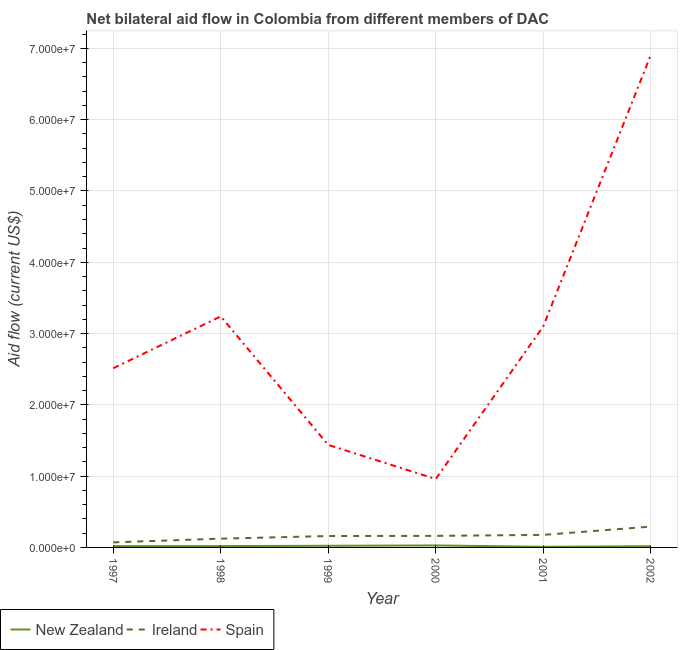Does the line corresponding to amount of aid provided by new zealand intersect with the line corresponding to amount of aid provided by ireland?
Provide a succinct answer. No. Is the number of lines equal to the number of legend labels?
Give a very brief answer. Yes. What is the amount of aid provided by new zealand in 2000?
Give a very brief answer. 2.80e+05. Across all years, what is the maximum amount of aid provided by spain?
Your response must be concise. 6.90e+07. Across all years, what is the minimum amount of aid provided by ireland?
Your answer should be compact. 7.10e+05. In which year was the amount of aid provided by ireland minimum?
Make the answer very short. 1997. What is the total amount of aid provided by new zealand in the graph?
Provide a short and direct response. 1.15e+06. What is the difference between the amount of aid provided by spain in 2000 and that in 2001?
Ensure brevity in your answer.  -2.14e+07. What is the difference between the amount of aid provided by spain in 1999 and the amount of aid provided by ireland in 2000?
Ensure brevity in your answer.  1.28e+07. What is the average amount of aid provided by new zealand per year?
Ensure brevity in your answer.  1.92e+05. In the year 2001, what is the difference between the amount of aid provided by spain and amount of aid provided by ireland?
Your answer should be very brief. 2.92e+07. What is the ratio of the amount of aid provided by spain in 1997 to that in 1999?
Offer a very short reply. 1.75. Is the difference between the amount of aid provided by spain in 1997 and 2001 greater than the difference between the amount of aid provided by ireland in 1997 and 2001?
Make the answer very short. No. What is the difference between the highest and the second highest amount of aid provided by spain?
Offer a very short reply. 3.66e+07. What is the difference between the highest and the lowest amount of aid provided by new zealand?
Keep it short and to the point. 1.90e+05. In how many years, is the amount of aid provided by spain greater than the average amount of aid provided by spain taken over all years?
Offer a very short reply. 3. Is the sum of the amount of aid provided by spain in 2000 and 2001 greater than the maximum amount of aid provided by new zealand across all years?
Give a very brief answer. Yes. Is it the case that in every year, the sum of the amount of aid provided by new zealand and amount of aid provided by ireland is greater than the amount of aid provided by spain?
Your response must be concise. No. Is the amount of aid provided by ireland strictly less than the amount of aid provided by spain over the years?
Provide a succinct answer. Yes. How many lines are there?
Ensure brevity in your answer.  3. What is the difference between two consecutive major ticks on the Y-axis?
Your response must be concise. 1.00e+07. Does the graph contain grids?
Provide a succinct answer. Yes. Where does the legend appear in the graph?
Keep it short and to the point. Bottom left. What is the title of the graph?
Your answer should be compact. Net bilateral aid flow in Colombia from different members of DAC. Does "Negligence towards kids" appear as one of the legend labels in the graph?
Provide a short and direct response. No. What is the Aid flow (current US$) of New Zealand in 1997?
Provide a short and direct response. 1.90e+05. What is the Aid flow (current US$) of Ireland in 1997?
Your answer should be very brief. 7.10e+05. What is the Aid flow (current US$) of Spain in 1997?
Offer a very short reply. 2.51e+07. What is the Aid flow (current US$) of New Zealand in 1998?
Offer a very short reply. 1.90e+05. What is the Aid flow (current US$) in Ireland in 1998?
Make the answer very short. 1.23e+06. What is the Aid flow (current US$) of Spain in 1998?
Offer a very short reply. 3.24e+07. What is the Aid flow (current US$) in New Zealand in 1999?
Make the answer very short. 2.30e+05. What is the Aid flow (current US$) in Ireland in 1999?
Provide a short and direct response. 1.60e+06. What is the Aid flow (current US$) in Spain in 1999?
Make the answer very short. 1.44e+07. What is the Aid flow (current US$) in New Zealand in 2000?
Offer a very short reply. 2.80e+05. What is the Aid flow (current US$) of Ireland in 2000?
Give a very brief answer. 1.62e+06. What is the Aid flow (current US$) in Spain in 2000?
Ensure brevity in your answer.  9.60e+06. What is the Aid flow (current US$) of New Zealand in 2001?
Your response must be concise. 9.00e+04. What is the Aid flow (current US$) in Ireland in 2001?
Offer a very short reply. 1.76e+06. What is the Aid flow (current US$) of Spain in 2001?
Offer a very short reply. 3.10e+07. What is the Aid flow (current US$) of Ireland in 2002?
Offer a very short reply. 2.92e+06. What is the Aid flow (current US$) in Spain in 2002?
Your answer should be compact. 6.90e+07. Across all years, what is the maximum Aid flow (current US$) of Ireland?
Your response must be concise. 2.92e+06. Across all years, what is the maximum Aid flow (current US$) of Spain?
Make the answer very short. 6.90e+07. Across all years, what is the minimum Aid flow (current US$) in New Zealand?
Provide a short and direct response. 9.00e+04. Across all years, what is the minimum Aid flow (current US$) in Ireland?
Offer a terse response. 7.10e+05. Across all years, what is the minimum Aid flow (current US$) in Spain?
Give a very brief answer. 9.60e+06. What is the total Aid flow (current US$) in New Zealand in the graph?
Make the answer very short. 1.15e+06. What is the total Aid flow (current US$) of Ireland in the graph?
Your answer should be compact. 9.84e+06. What is the total Aid flow (current US$) in Spain in the graph?
Give a very brief answer. 1.82e+08. What is the difference between the Aid flow (current US$) in Ireland in 1997 and that in 1998?
Ensure brevity in your answer.  -5.20e+05. What is the difference between the Aid flow (current US$) of Spain in 1997 and that in 1998?
Your answer should be compact. -7.27e+06. What is the difference between the Aid flow (current US$) of New Zealand in 1997 and that in 1999?
Your answer should be compact. -4.00e+04. What is the difference between the Aid flow (current US$) in Ireland in 1997 and that in 1999?
Offer a very short reply. -8.90e+05. What is the difference between the Aid flow (current US$) of Spain in 1997 and that in 1999?
Your answer should be compact. 1.08e+07. What is the difference between the Aid flow (current US$) in Ireland in 1997 and that in 2000?
Offer a very short reply. -9.10e+05. What is the difference between the Aid flow (current US$) of Spain in 1997 and that in 2000?
Provide a short and direct response. 1.55e+07. What is the difference between the Aid flow (current US$) of New Zealand in 1997 and that in 2001?
Your answer should be very brief. 1.00e+05. What is the difference between the Aid flow (current US$) of Ireland in 1997 and that in 2001?
Provide a succinct answer. -1.05e+06. What is the difference between the Aid flow (current US$) of Spain in 1997 and that in 2001?
Ensure brevity in your answer.  -5.84e+06. What is the difference between the Aid flow (current US$) in New Zealand in 1997 and that in 2002?
Give a very brief answer. 2.00e+04. What is the difference between the Aid flow (current US$) of Ireland in 1997 and that in 2002?
Make the answer very short. -2.21e+06. What is the difference between the Aid flow (current US$) of Spain in 1997 and that in 2002?
Ensure brevity in your answer.  -4.39e+07. What is the difference between the Aid flow (current US$) in Ireland in 1998 and that in 1999?
Make the answer very short. -3.70e+05. What is the difference between the Aid flow (current US$) of Spain in 1998 and that in 1999?
Your answer should be compact. 1.80e+07. What is the difference between the Aid flow (current US$) in Ireland in 1998 and that in 2000?
Your answer should be compact. -3.90e+05. What is the difference between the Aid flow (current US$) of Spain in 1998 and that in 2000?
Provide a succinct answer. 2.28e+07. What is the difference between the Aid flow (current US$) of Ireland in 1998 and that in 2001?
Your answer should be very brief. -5.30e+05. What is the difference between the Aid flow (current US$) in Spain in 1998 and that in 2001?
Provide a short and direct response. 1.43e+06. What is the difference between the Aid flow (current US$) of Ireland in 1998 and that in 2002?
Ensure brevity in your answer.  -1.69e+06. What is the difference between the Aid flow (current US$) in Spain in 1998 and that in 2002?
Offer a very short reply. -3.66e+07. What is the difference between the Aid flow (current US$) in New Zealand in 1999 and that in 2000?
Provide a succinct answer. -5.00e+04. What is the difference between the Aid flow (current US$) of Ireland in 1999 and that in 2000?
Your answer should be compact. -2.00e+04. What is the difference between the Aid flow (current US$) of Spain in 1999 and that in 2000?
Keep it short and to the point. 4.78e+06. What is the difference between the Aid flow (current US$) of New Zealand in 1999 and that in 2001?
Offer a terse response. 1.40e+05. What is the difference between the Aid flow (current US$) of Ireland in 1999 and that in 2001?
Offer a terse response. -1.60e+05. What is the difference between the Aid flow (current US$) in Spain in 1999 and that in 2001?
Provide a succinct answer. -1.66e+07. What is the difference between the Aid flow (current US$) of New Zealand in 1999 and that in 2002?
Offer a very short reply. 6.00e+04. What is the difference between the Aid flow (current US$) in Ireland in 1999 and that in 2002?
Ensure brevity in your answer.  -1.32e+06. What is the difference between the Aid flow (current US$) in Spain in 1999 and that in 2002?
Your answer should be compact. -5.46e+07. What is the difference between the Aid flow (current US$) of New Zealand in 2000 and that in 2001?
Offer a terse response. 1.90e+05. What is the difference between the Aid flow (current US$) in Ireland in 2000 and that in 2001?
Ensure brevity in your answer.  -1.40e+05. What is the difference between the Aid flow (current US$) of Spain in 2000 and that in 2001?
Your response must be concise. -2.14e+07. What is the difference between the Aid flow (current US$) in Ireland in 2000 and that in 2002?
Ensure brevity in your answer.  -1.30e+06. What is the difference between the Aid flow (current US$) in Spain in 2000 and that in 2002?
Ensure brevity in your answer.  -5.94e+07. What is the difference between the Aid flow (current US$) in Ireland in 2001 and that in 2002?
Give a very brief answer. -1.16e+06. What is the difference between the Aid flow (current US$) of Spain in 2001 and that in 2002?
Provide a short and direct response. -3.80e+07. What is the difference between the Aid flow (current US$) of New Zealand in 1997 and the Aid flow (current US$) of Ireland in 1998?
Provide a succinct answer. -1.04e+06. What is the difference between the Aid flow (current US$) in New Zealand in 1997 and the Aid flow (current US$) in Spain in 1998?
Give a very brief answer. -3.22e+07. What is the difference between the Aid flow (current US$) in Ireland in 1997 and the Aid flow (current US$) in Spain in 1998?
Offer a very short reply. -3.17e+07. What is the difference between the Aid flow (current US$) in New Zealand in 1997 and the Aid flow (current US$) in Ireland in 1999?
Offer a terse response. -1.41e+06. What is the difference between the Aid flow (current US$) in New Zealand in 1997 and the Aid flow (current US$) in Spain in 1999?
Give a very brief answer. -1.42e+07. What is the difference between the Aid flow (current US$) in Ireland in 1997 and the Aid flow (current US$) in Spain in 1999?
Make the answer very short. -1.37e+07. What is the difference between the Aid flow (current US$) of New Zealand in 1997 and the Aid flow (current US$) of Ireland in 2000?
Offer a very short reply. -1.43e+06. What is the difference between the Aid flow (current US$) of New Zealand in 1997 and the Aid flow (current US$) of Spain in 2000?
Keep it short and to the point. -9.41e+06. What is the difference between the Aid flow (current US$) of Ireland in 1997 and the Aid flow (current US$) of Spain in 2000?
Your response must be concise. -8.89e+06. What is the difference between the Aid flow (current US$) of New Zealand in 1997 and the Aid flow (current US$) of Ireland in 2001?
Offer a terse response. -1.57e+06. What is the difference between the Aid flow (current US$) in New Zealand in 1997 and the Aid flow (current US$) in Spain in 2001?
Your response must be concise. -3.08e+07. What is the difference between the Aid flow (current US$) of Ireland in 1997 and the Aid flow (current US$) of Spain in 2001?
Your answer should be very brief. -3.03e+07. What is the difference between the Aid flow (current US$) of New Zealand in 1997 and the Aid flow (current US$) of Ireland in 2002?
Offer a terse response. -2.73e+06. What is the difference between the Aid flow (current US$) in New Zealand in 1997 and the Aid flow (current US$) in Spain in 2002?
Your response must be concise. -6.88e+07. What is the difference between the Aid flow (current US$) of Ireland in 1997 and the Aid flow (current US$) of Spain in 2002?
Ensure brevity in your answer.  -6.83e+07. What is the difference between the Aid flow (current US$) in New Zealand in 1998 and the Aid flow (current US$) in Ireland in 1999?
Your response must be concise. -1.41e+06. What is the difference between the Aid flow (current US$) in New Zealand in 1998 and the Aid flow (current US$) in Spain in 1999?
Give a very brief answer. -1.42e+07. What is the difference between the Aid flow (current US$) of Ireland in 1998 and the Aid flow (current US$) of Spain in 1999?
Your answer should be compact. -1.32e+07. What is the difference between the Aid flow (current US$) of New Zealand in 1998 and the Aid flow (current US$) of Ireland in 2000?
Give a very brief answer. -1.43e+06. What is the difference between the Aid flow (current US$) in New Zealand in 1998 and the Aid flow (current US$) in Spain in 2000?
Ensure brevity in your answer.  -9.41e+06. What is the difference between the Aid flow (current US$) in Ireland in 1998 and the Aid flow (current US$) in Spain in 2000?
Offer a terse response. -8.37e+06. What is the difference between the Aid flow (current US$) of New Zealand in 1998 and the Aid flow (current US$) of Ireland in 2001?
Keep it short and to the point. -1.57e+06. What is the difference between the Aid flow (current US$) of New Zealand in 1998 and the Aid flow (current US$) of Spain in 2001?
Offer a very short reply. -3.08e+07. What is the difference between the Aid flow (current US$) of Ireland in 1998 and the Aid flow (current US$) of Spain in 2001?
Give a very brief answer. -2.98e+07. What is the difference between the Aid flow (current US$) in New Zealand in 1998 and the Aid flow (current US$) in Ireland in 2002?
Offer a very short reply. -2.73e+06. What is the difference between the Aid flow (current US$) in New Zealand in 1998 and the Aid flow (current US$) in Spain in 2002?
Offer a very short reply. -6.88e+07. What is the difference between the Aid flow (current US$) of Ireland in 1998 and the Aid flow (current US$) of Spain in 2002?
Give a very brief answer. -6.78e+07. What is the difference between the Aid flow (current US$) of New Zealand in 1999 and the Aid flow (current US$) of Ireland in 2000?
Provide a short and direct response. -1.39e+06. What is the difference between the Aid flow (current US$) of New Zealand in 1999 and the Aid flow (current US$) of Spain in 2000?
Provide a succinct answer. -9.37e+06. What is the difference between the Aid flow (current US$) in Ireland in 1999 and the Aid flow (current US$) in Spain in 2000?
Your answer should be very brief. -8.00e+06. What is the difference between the Aid flow (current US$) of New Zealand in 1999 and the Aid flow (current US$) of Ireland in 2001?
Your answer should be very brief. -1.53e+06. What is the difference between the Aid flow (current US$) in New Zealand in 1999 and the Aid flow (current US$) in Spain in 2001?
Give a very brief answer. -3.08e+07. What is the difference between the Aid flow (current US$) of Ireland in 1999 and the Aid flow (current US$) of Spain in 2001?
Your answer should be compact. -2.94e+07. What is the difference between the Aid flow (current US$) of New Zealand in 1999 and the Aid flow (current US$) of Ireland in 2002?
Ensure brevity in your answer.  -2.69e+06. What is the difference between the Aid flow (current US$) in New Zealand in 1999 and the Aid flow (current US$) in Spain in 2002?
Provide a short and direct response. -6.88e+07. What is the difference between the Aid flow (current US$) of Ireland in 1999 and the Aid flow (current US$) of Spain in 2002?
Provide a succinct answer. -6.74e+07. What is the difference between the Aid flow (current US$) in New Zealand in 2000 and the Aid flow (current US$) in Ireland in 2001?
Your answer should be compact. -1.48e+06. What is the difference between the Aid flow (current US$) of New Zealand in 2000 and the Aid flow (current US$) of Spain in 2001?
Your response must be concise. -3.07e+07. What is the difference between the Aid flow (current US$) in Ireland in 2000 and the Aid flow (current US$) in Spain in 2001?
Your response must be concise. -2.94e+07. What is the difference between the Aid flow (current US$) of New Zealand in 2000 and the Aid flow (current US$) of Ireland in 2002?
Give a very brief answer. -2.64e+06. What is the difference between the Aid flow (current US$) in New Zealand in 2000 and the Aid flow (current US$) in Spain in 2002?
Your response must be concise. -6.87e+07. What is the difference between the Aid flow (current US$) of Ireland in 2000 and the Aid flow (current US$) of Spain in 2002?
Provide a short and direct response. -6.74e+07. What is the difference between the Aid flow (current US$) of New Zealand in 2001 and the Aid flow (current US$) of Ireland in 2002?
Provide a succinct answer. -2.83e+06. What is the difference between the Aid flow (current US$) in New Zealand in 2001 and the Aid flow (current US$) in Spain in 2002?
Offer a terse response. -6.89e+07. What is the difference between the Aid flow (current US$) in Ireland in 2001 and the Aid flow (current US$) in Spain in 2002?
Your answer should be very brief. -6.73e+07. What is the average Aid flow (current US$) of New Zealand per year?
Provide a succinct answer. 1.92e+05. What is the average Aid flow (current US$) of Ireland per year?
Make the answer very short. 1.64e+06. What is the average Aid flow (current US$) in Spain per year?
Your answer should be compact. 3.03e+07. In the year 1997, what is the difference between the Aid flow (current US$) of New Zealand and Aid flow (current US$) of Ireland?
Your response must be concise. -5.20e+05. In the year 1997, what is the difference between the Aid flow (current US$) of New Zealand and Aid flow (current US$) of Spain?
Provide a succinct answer. -2.50e+07. In the year 1997, what is the difference between the Aid flow (current US$) of Ireland and Aid flow (current US$) of Spain?
Give a very brief answer. -2.44e+07. In the year 1998, what is the difference between the Aid flow (current US$) in New Zealand and Aid flow (current US$) in Ireland?
Ensure brevity in your answer.  -1.04e+06. In the year 1998, what is the difference between the Aid flow (current US$) in New Zealand and Aid flow (current US$) in Spain?
Your answer should be very brief. -3.22e+07. In the year 1998, what is the difference between the Aid flow (current US$) of Ireland and Aid flow (current US$) of Spain?
Provide a short and direct response. -3.12e+07. In the year 1999, what is the difference between the Aid flow (current US$) in New Zealand and Aid flow (current US$) in Ireland?
Give a very brief answer. -1.37e+06. In the year 1999, what is the difference between the Aid flow (current US$) of New Zealand and Aid flow (current US$) of Spain?
Offer a terse response. -1.42e+07. In the year 1999, what is the difference between the Aid flow (current US$) of Ireland and Aid flow (current US$) of Spain?
Give a very brief answer. -1.28e+07. In the year 2000, what is the difference between the Aid flow (current US$) in New Zealand and Aid flow (current US$) in Ireland?
Provide a succinct answer. -1.34e+06. In the year 2000, what is the difference between the Aid flow (current US$) of New Zealand and Aid flow (current US$) of Spain?
Give a very brief answer. -9.32e+06. In the year 2000, what is the difference between the Aid flow (current US$) of Ireland and Aid flow (current US$) of Spain?
Provide a succinct answer. -7.98e+06. In the year 2001, what is the difference between the Aid flow (current US$) of New Zealand and Aid flow (current US$) of Ireland?
Your answer should be very brief. -1.67e+06. In the year 2001, what is the difference between the Aid flow (current US$) in New Zealand and Aid flow (current US$) in Spain?
Keep it short and to the point. -3.09e+07. In the year 2001, what is the difference between the Aid flow (current US$) in Ireland and Aid flow (current US$) in Spain?
Offer a very short reply. -2.92e+07. In the year 2002, what is the difference between the Aid flow (current US$) of New Zealand and Aid flow (current US$) of Ireland?
Provide a succinct answer. -2.75e+06. In the year 2002, what is the difference between the Aid flow (current US$) of New Zealand and Aid flow (current US$) of Spain?
Ensure brevity in your answer.  -6.88e+07. In the year 2002, what is the difference between the Aid flow (current US$) of Ireland and Aid flow (current US$) of Spain?
Your response must be concise. -6.61e+07. What is the ratio of the Aid flow (current US$) of New Zealand in 1997 to that in 1998?
Provide a succinct answer. 1. What is the ratio of the Aid flow (current US$) in Ireland in 1997 to that in 1998?
Your response must be concise. 0.58. What is the ratio of the Aid flow (current US$) of Spain in 1997 to that in 1998?
Offer a very short reply. 0.78. What is the ratio of the Aid flow (current US$) in New Zealand in 1997 to that in 1999?
Keep it short and to the point. 0.83. What is the ratio of the Aid flow (current US$) of Ireland in 1997 to that in 1999?
Your response must be concise. 0.44. What is the ratio of the Aid flow (current US$) in Spain in 1997 to that in 1999?
Your answer should be compact. 1.75. What is the ratio of the Aid flow (current US$) of New Zealand in 1997 to that in 2000?
Your answer should be compact. 0.68. What is the ratio of the Aid flow (current US$) of Ireland in 1997 to that in 2000?
Provide a succinct answer. 0.44. What is the ratio of the Aid flow (current US$) in Spain in 1997 to that in 2000?
Offer a very short reply. 2.62. What is the ratio of the Aid flow (current US$) in New Zealand in 1997 to that in 2001?
Make the answer very short. 2.11. What is the ratio of the Aid flow (current US$) in Ireland in 1997 to that in 2001?
Make the answer very short. 0.4. What is the ratio of the Aid flow (current US$) of Spain in 1997 to that in 2001?
Keep it short and to the point. 0.81. What is the ratio of the Aid flow (current US$) of New Zealand in 1997 to that in 2002?
Offer a terse response. 1.12. What is the ratio of the Aid flow (current US$) of Ireland in 1997 to that in 2002?
Provide a succinct answer. 0.24. What is the ratio of the Aid flow (current US$) of Spain in 1997 to that in 2002?
Your answer should be very brief. 0.36. What is the ratio of the Aid flow (current US$) of New Zealand in 1998 to that in 1999?
Offer a terse response. 0.83. What is the ratio of the Aid flow (current US$) in Ireland in 1998 to that in 1999?
Make the answer very short. 0.77. What is the ratio of the Aid flow (current US$) of Spain in 1998 to that in 1999?
Offer a terse response. 2.25. What is the ratio of the Aid flow (current US$) in New Zealand in 1998 to that in 2000?
Provide a short and direct response. 0.68. What is the ratio of the Aid flow (current US$) in Ireland in 1998 to that in 2000?
Your answer should be compact. 0.76. What is the ratio of the Aid flow (current US$) of Spain in 1998 to that in 2000?
Your response must be concise. 3.38. What is the ratio of the Aid flow (current US$) in New Zealand in 1998 to that in 2001?
Ensure brevity in your answer.  2.11. What is the ratio of the Aid flow (current US$) of Ireland in 1998 to that in 2001?
Offer a very short reply. 0.7. What is the ratio of the Aid flow (current US$) of Spain in 1998 to that in 2001?
Offer a terse response. 1.05. What is the ratio of the Aid flow (current US$) of New Zealand in 1998 to that in 2002?
Give a very brief answer. 1.12. What is the ratio of the Aid flow (current US$) of Ireland in 1998 to that in 2002?
Your answer should be compact. 0.42. What is the ratio of the Aid flow (current US$) of Spain in 1998 to that in 2002?
Give a very brief answer. 0.47. What is the ratio of the Aid flow (current US$) of New Zealand in 1999 to that in 2000?
Offer a very short reply. 0.82. What is the ratio of the Aid flow (current US$) in Ireland in 1999 to that in 2000?
Offer a terse response. 0.99. What is the ratio of the Aid flow (current US$) of Spain in 1999 to that in 2000?
Make the answer very short. 1.5. What is the ratio of the Aid flow (current US$) in New Zealand in 1999 to that in 2001?
Your answer should be very brief. 2.56. What is the ratio of the Aid flow (current US$) in Spain in 1999 to that in 2001?
Your response must be concise. 0.46. What is the ratio of the Aid flow (current US$) of New Zealand in 1999 to that in 2002?
Provide a succinct answer. 1.35. What is the ratio of the Aid flow (current US$) of Ireland in 1999 to that in 2002?
Keep it short and to the point. 0.55. What is the ratio of the Aid flow (current US$) of Spain in 1999 to that in 2002?
Offer a terse response. 0.21. What is the ratio of the Aid flow (current US$) in New Zealand in 2000 to that in 2001?
Your answer should be very brief. 3.11. What is the ratio of the Aid flow (current US$) in Ireland in 2000 to that in 2001?
Make the answer very short. 0.92. What is the ratio of the Aid flow (current US$) in Spain in 2000 to that in 2001?
Offer a very short reply. 0.31. What is the ratio of the Aid flow (current US$) in New Zealand in 2000 to that in 2002?
Offer a terse response. 1.65. What is the ratio of the Aid flow (current US$) of Ireland in 2000 to that in 2002?
Provide a succinct answer. 0.55. What is the ratio of the Aid flow (current US$) in Spain in 2000 to that in 2002?
Your answer should be very brief. 0.14. What is the ratio of the Aid flow (current US$) of New Zealand in 2001 to that in 2002?
Provide a succinct answer. 0.53. What is the ratio of the Aid flow (current US$) in Ireland in 2001 to that in 2002?
Keep it short and to the point. 0.6. What is the ratio of the Aid flow (current US$) in Spain in 2001 to that in 2002?
Give a very brief answer. 0.45. What is the difference between the highest and the second highest Aid flow (current US$) of New Zealand?
Your answer should be compact. 5.00e+04. What is the difference between the highest and the second highest Aid flow (current US$) in Ireland?
Your response must be concise. 1.16e+06. What is the difference between the highest and the second highest Aid flow (current US$) of Spain?
Offer a terse response. 3.66e+07. What is the difference between the highest and the lowest Aid flow (current US$) in New Zealand?
Your response must be concise. 1.90e+05. What is the difference between the highest and the lowest Aid flow (current US$) in Ireland?
Give a very brief answer. 2.21e+06. What is the difference between the highest and the lowest Aid flow (current US$) in Spain?
Make the answer very short. 5.94e+07. 